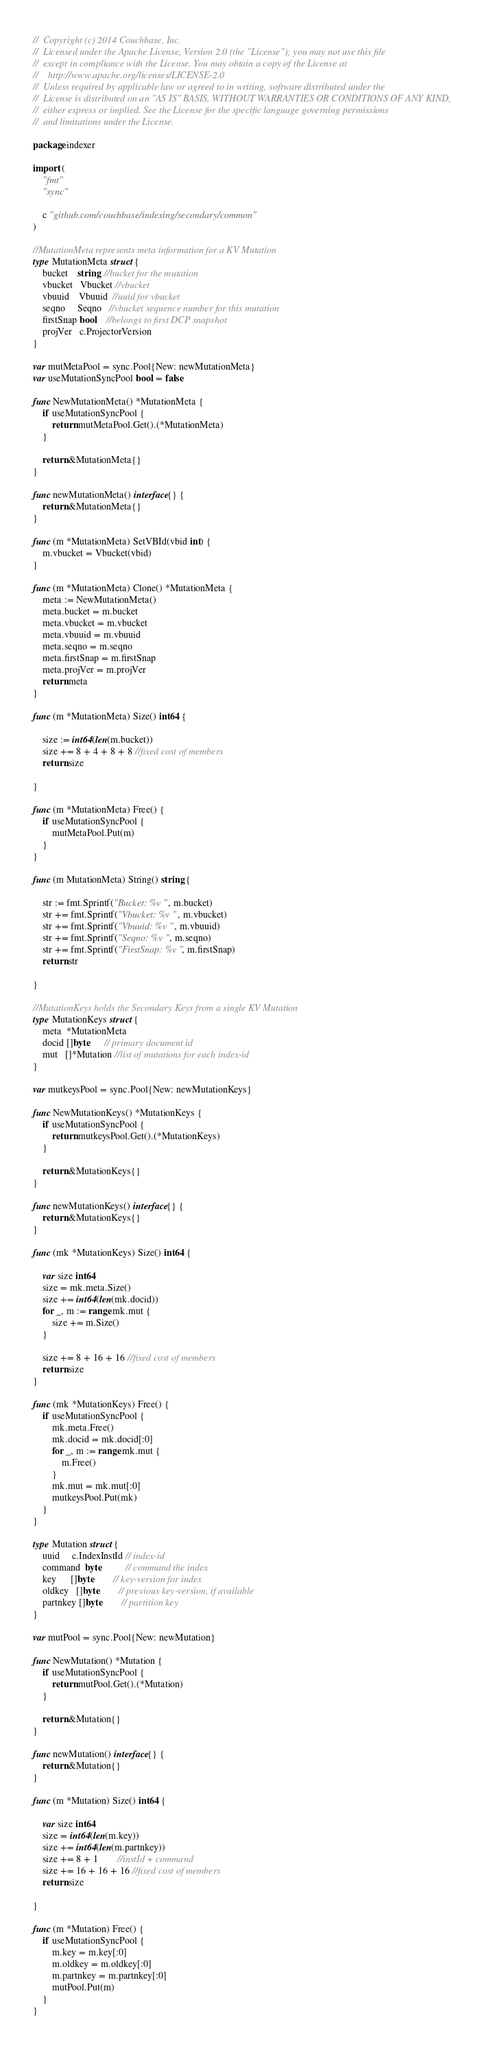Convert code to text. <code><loc_0><loc_0><loc_500><loc_500><_Go_>//  Copyright (c) 2014 Couchbase, Inc.
//  Licensed under the Apache License, Version 2.0 (the "License"); you may not use this file
//  except in compliance with the License. You may obtain a copy of the License at
//    http://www.apache.org/licenses/LICENSE-2.0
//  Unless required by applicable law or agreed to in writing, software distributed under the
//  License is distributed on an "AS IS" BASIS, WITHOUT WARRANTIES OR CONDITIONS OF ANY KIND,
//  either express or implied. See the License for the specific language governing permissions
//  and limitations under the License.

package indexer

import (
	"fmt"
	"sync"

	c "github.com/couchbase/indexing/secondary/common"
)

//MutationMeta represents meta information for a KV Mutation
type MutationMeta struct {
	bucket    string  //bucket for the mutation
	vbucket   Vbucket //vbucket
	vbuuid    Vbuuid  //uuid for vbucket
	seqno     Seqno   //vbucket sequence number for this mutation
	firstSnap bool    //belongs to first DCP snapshot
	projVer   c.ProjectorVersion
}

var mutMetaPool = sync.Pool{New: newMutationMeta}
var useMutationSyncPool bool = false

func NewMutationMeta() *MutationMeta {
	if useMutationSyncPool {
		return mutMetaPool.Get().(*MutationMeta)
	}

	return &MutationMeta{}
}

func newMutationMeta() interface{} {
	return &MutationMeta{}
}

func (m *MutationMeta) SetVBId(vbid int) {
	m.vbucket = Vbucket(vbid)
}

func (m *MutationMeta) Clone() *MutationMeta {
	meta := NewMutationMeta()
	meta.bucket = m.bucket
	meta.vbucket = m.vbucket
	meta.vbuuid = m.vbuuid
	meta.seqno = m.seqno
	meta.firstSnap = m.firstSnap
	meta.projVer = m.projVer
	return meta
}

func (m *MutationMeta) Size() int64 {

	size := int64(len(m.bucket))
	size += 8 + 4 + 8 + 8 //fixed cost of members
	return size

}

func (m *MutationMeta) Free() {
	if useMutationSyncPool {
		mutMetaPool.Put(m)
	}
}

func (m MutationMeta) String() string {

	str := fmt.Sprintf("Bucket: %v ", m.bucket)
	str += fmt.Sprintf("Vbucket: %v ", m.vbucket)
	str += fmt.Sprintf("Vbuuid: %v ", m.vbuuid)
	str += fmt.Sprintf("Seqno: %v ", m.seqno)
	str += fmt.Sprintf("FirstSnap: %v ", m.firstSnap)
	return str

}

//MutationKeys holds the Secondary Keys from a single KV Mutation
type MutationKeys struct {
	meta  *MutationMeta
	docid []byte      // primary document id
	mut   []*Mutation //list of mutations for each index-id
}

var mutkeysPool = sync.Pool{New: newMutationKeys}

func NewMutationKeys() *MutationKeys {
	if useMutationSyncPool {
		return mutkeysPool.Get().(*MutationKeys)
	}

	return &MutationKeys{}
}

func newMutationKeys() interface{} {
	return &MutationKeys{}
}

func (mk *MutationKeys) Size() int64 {

	var size int64
	size = mk.meta.Size()
	size += int64(len(mk.docid))
	for _, m := range mk.mut {
		size += m.Size()
	}

	size += 8 + 16 + 16 //fixed cost of members
	return size
}

func (mk *MutationKeys) Free() {
	if useMutationSyncPool {
		mk.meta.Free()
		mk.docid = mk.docid[:0]
		for _, m := range mk.mut {
			m.Free()
		}
		mk.mut = mk.mut[:0]
		mutkeysPool.Put(mk)
	}
}

type Mutation struct {
	uuid     c.IndexInstId // index-id
	command  byte          // command the index
	key      []byte        // key-version for index
	oldkey   []byte        // previous key-version, if available
	partnkey []byte        // partition key
}

var mutPool = sync.Pool{New: newMutation}

func NewMutation() *Mutation {
	if useMutationSyncPool {
		return mutPool.Get().(*Mutation)
	}

	return &Mutation{}
}

func newMutation() interface{} {
	return &Mutation{}
}

func (m *Mutation) Size() int64 {

	var size int64
	size = int64(len(m.key))
	size += int64(len(m.partnkey))
	size += 8 + 1        //instId + command
	size += 16 + 16 + 16 //fixed cost of members
	return size

}

func (m *Mutation) Free() {
	if useMutationSyncPool {
		m.key = m.key[:0]
		m.oldkey = m.oldkey[:0]
		m.partnkey = m.partnkey[:0]
		mutPool.Put(m)
	}
}
</code> 